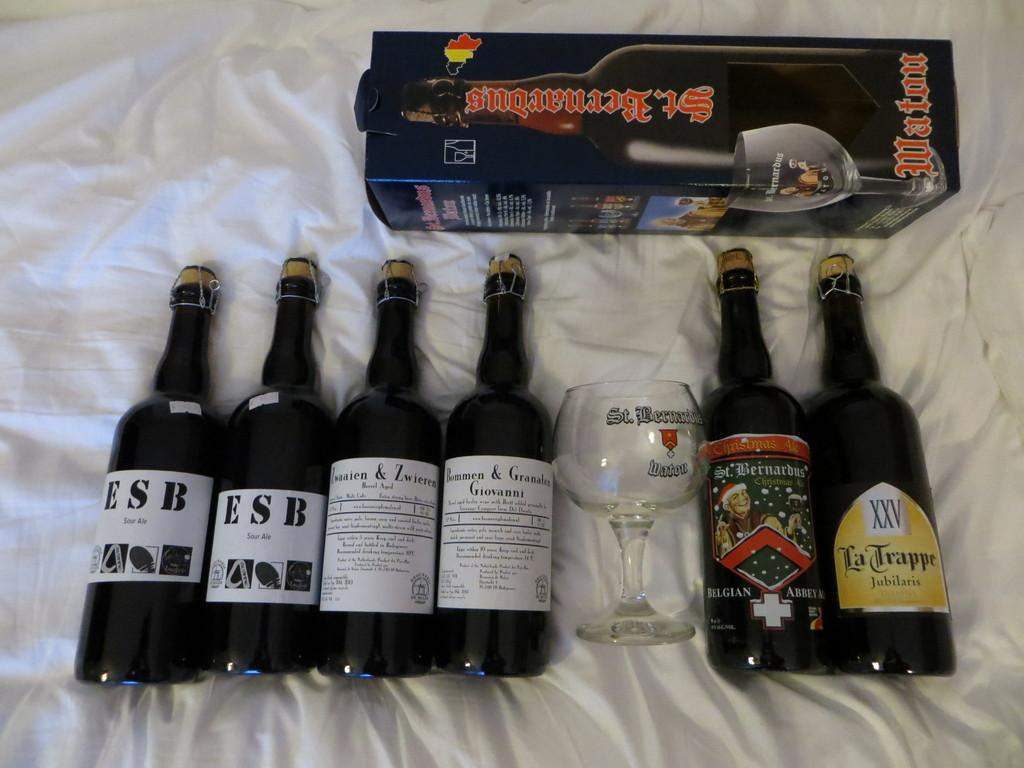<image>
Offer a succinct explanation of the picture presented. Two bottles of ESB sour ale sit next to some other alcohol bottles. 